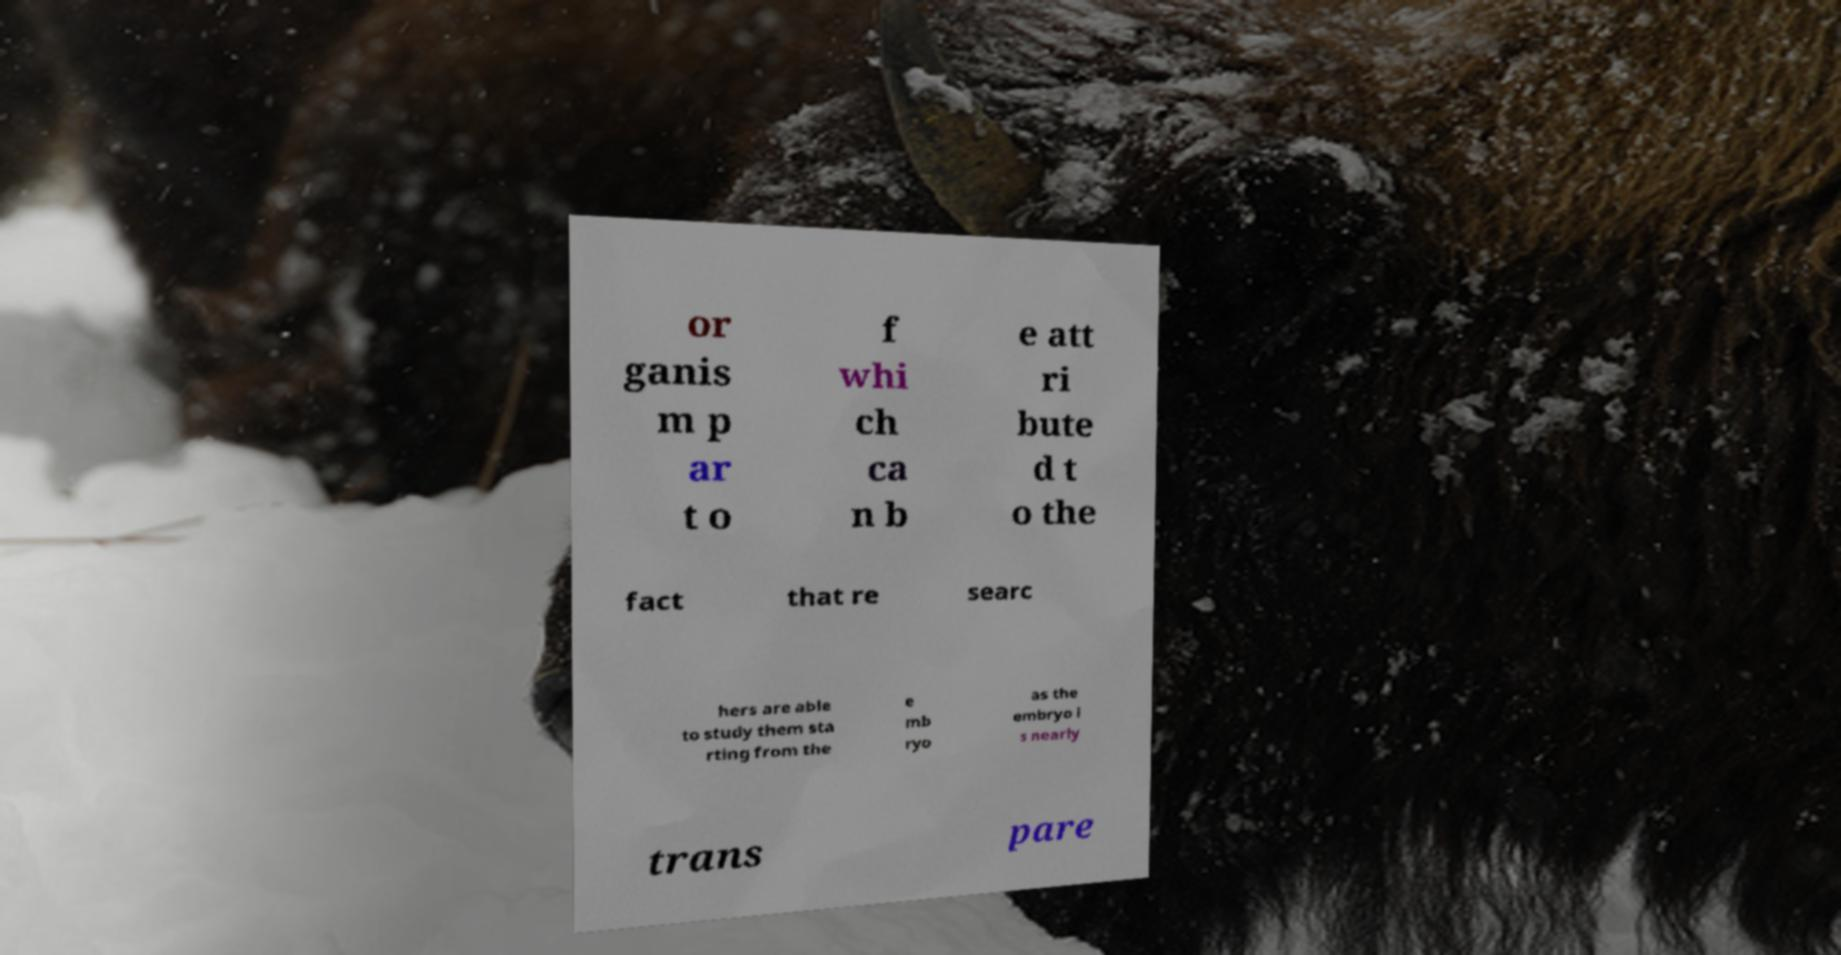I need the written content from this picture converted into text. Can you do that? or ganis m p ar t o f whi ch ca n b e att ri bute d t o the fact that re searc hers are able to study them sta rting from the e mb ryo as the embryo i s nearly trans pare 